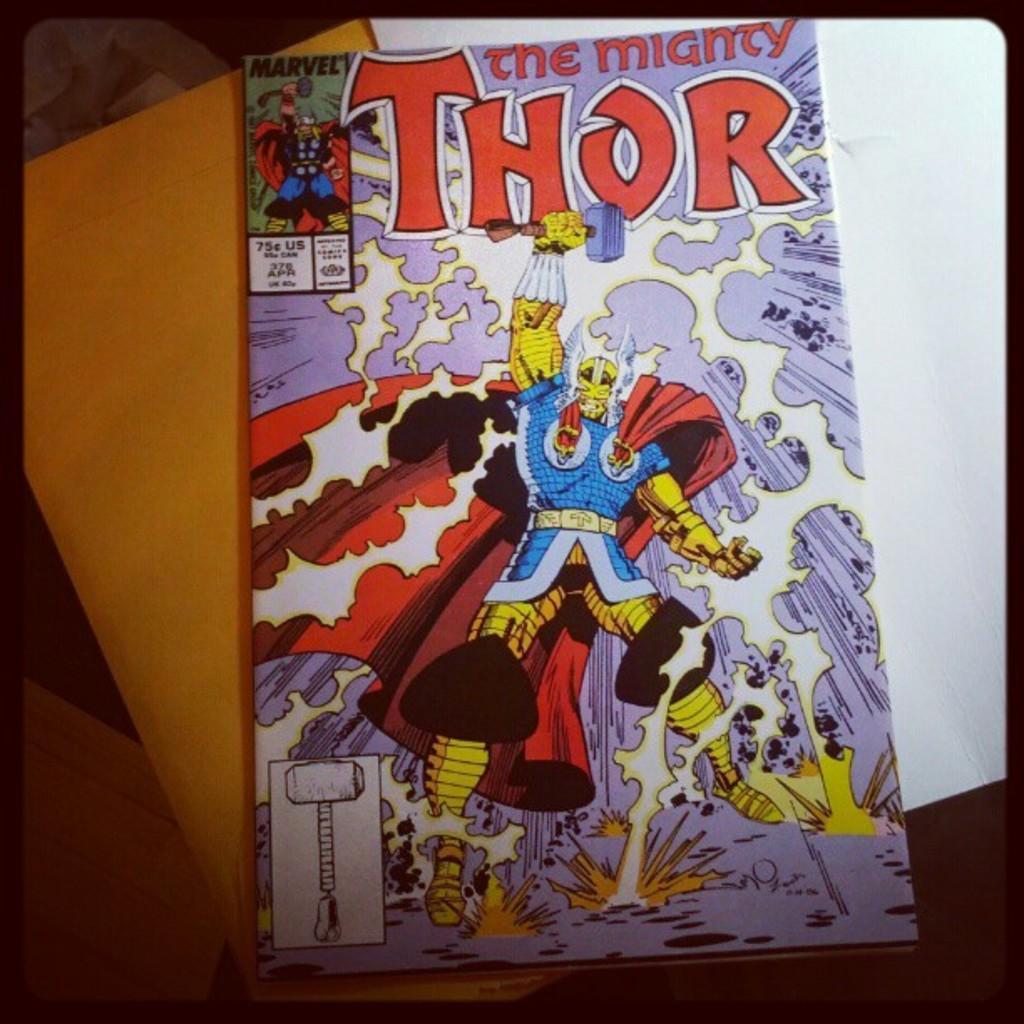Could you give a brief overview of what you see in this image? In this image we can see cover page of a book with some text. In the background, we can see white and orange color paper. 